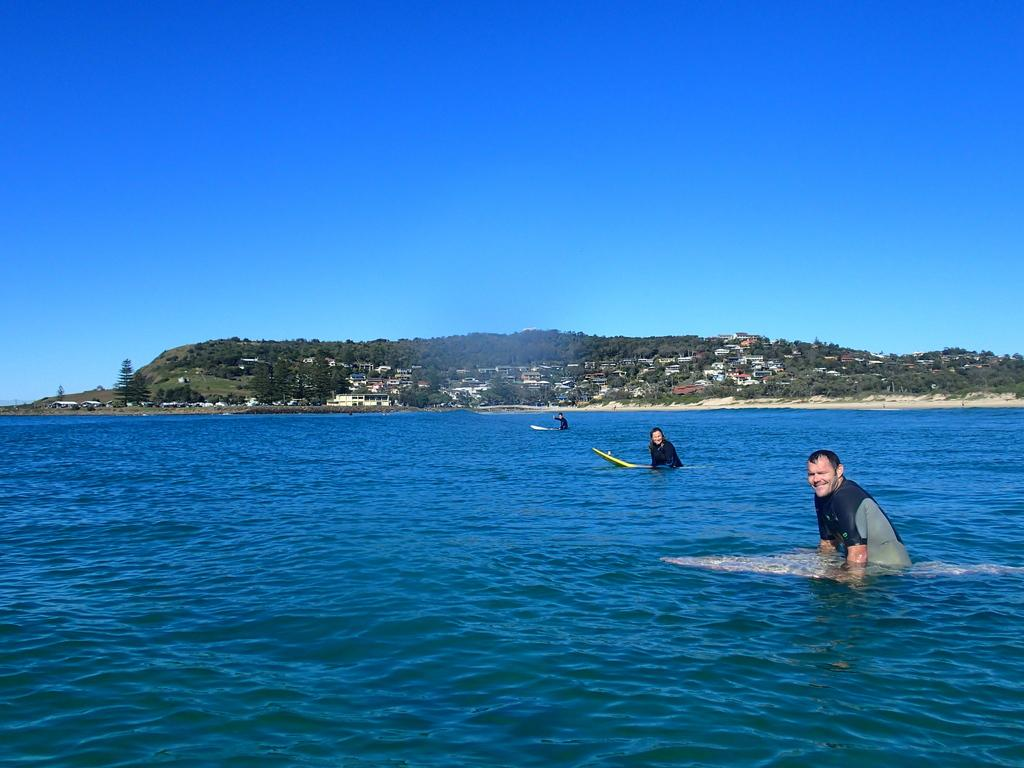What is located in the front of the image? There is water in the front of the image. What are the people in the image doing? There are persons in the water, which suggests they might be swimming or playing. What can be seen in the background of the image? There are trees and houses in the background of the image. What type of furniture can be seen in the image? There is no furniture present in the image; it features water, people, trees, and houses. What is the title of the image? The image does not have a title, as it is a photograph or illustration without accompanying text. 